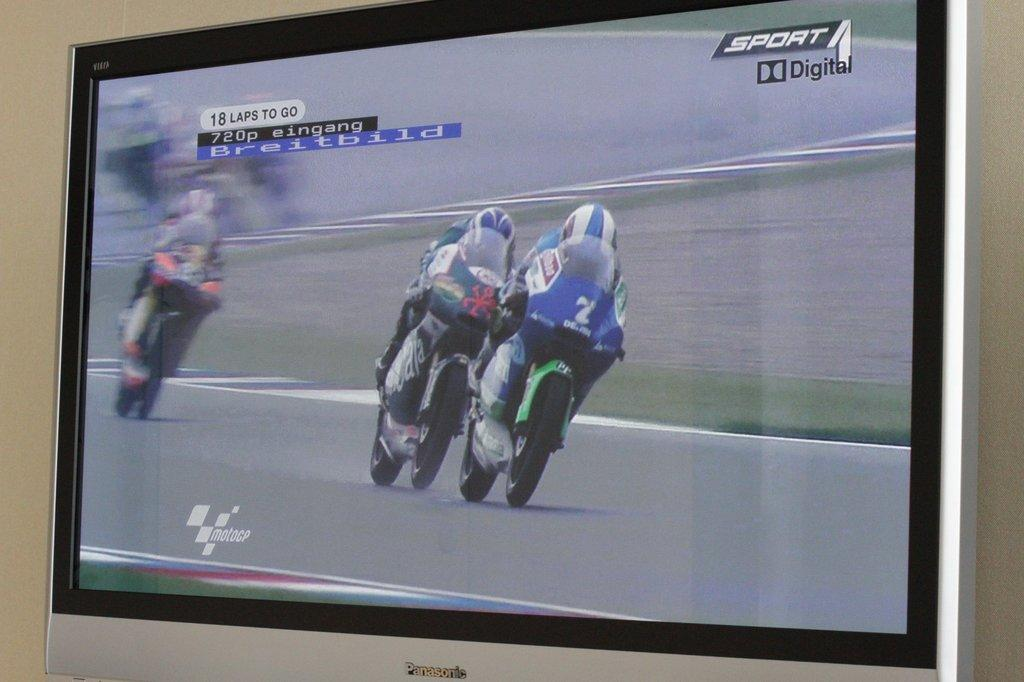<image>
Provide a brief description of the given image. Screen showing two bikers and the word "Sport Digital" on the top. 